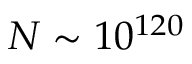<formula> <loc_0><loc_0><loc_500><loc_500>N \sim 1 0 ^ { 1 2 0 }</formula> 